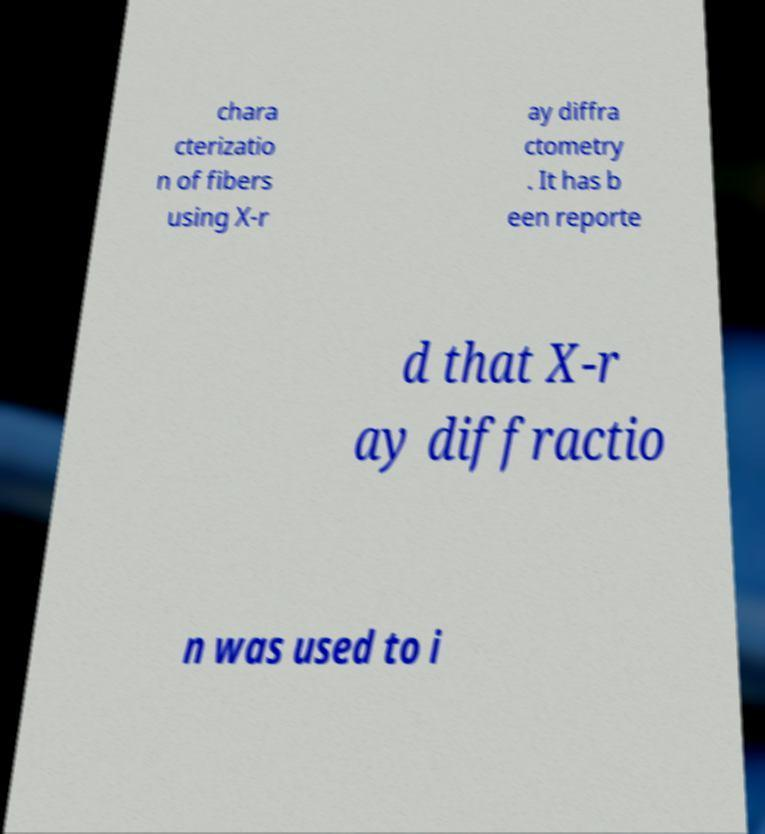Please identify and transcribe the text found in this image. chara cterizatio n of fibers using X-r ay diffra ctometry . It has b een reporte d that X-r ay diffractio n was used to i 